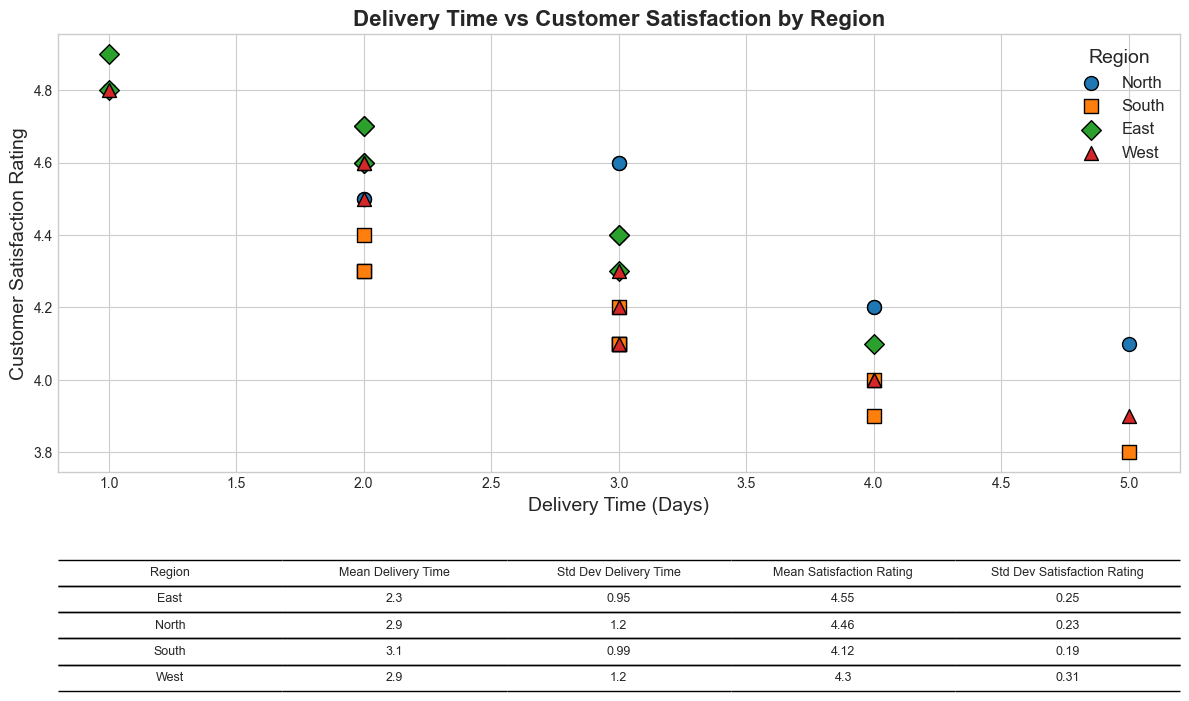What is the average delivery time for the North region? The table in the chart shows the mean delivery time for each region. For the North region, look for the value in the column labeled 'Mean Delivery Time' corresponding to 'North'.
Answer: 2.90 Which region has the highest average customer satisfaction rating? The table in the chart provides the mean satisfaction ratings for each region. Compare these values to determine the highest. The region with the highest value in the 'Mean Satisfaction Rating' column is East.
Answer: East What is the standard deviation of delivery time in the South region? From the table, find the row corresponding to the South region and look at the value under the 'Std Dev Delivery Time' column.
Answer: 1.14 Which region shows the lowest customer satisfaction rating on average? The table lists the mean satisfaction ratings for all regions. Identify the region with the lowest figure in the 'Mean Satisfaction Rating' column. The South region has the lowest average rating.
Answer: South How many points indicate a delivery time of 2 days in the East region? From the scatter plot, locate the East region points, identified by their specific color and marker, and count how many of these points are positioned at a delivery time of 2 days on the x-axis.
Answer: 4 Between which two regions is the difference in average delivery time the largest? Check the 'Mean Delivery Time' values for all regions in the table, then calculate the difference between each pair to identify the largest one. Compare the mean delivery times of the East (2.30 days) and South (3.10 days) regions. The difference is 0.80 days.
Answer: East and South Which region has the most variability in customer satisfaction ratings? The table shows the standard deviation for satisfaction ratings of each region. The region with the highest value in the 'Std Dev Satisfaction Rating' column represents the highest variability. North has the highest standard deviation.
Answer: North Does any region have both the highest mean delivery time and the highest standard deviation in delivery times? Compare the values in the table: the highest mean delivery time is 3.10 days (South) and the highest standard deviation in delivery times is 1.34 days (North). No single region has both the highest mean and highest variation.
Answer: No What is the correlation direction between delivery time and customer satisfaction in the West region? Examine the West region scatter plot points. Observe the trend: as delivery time decreases, customer satisfaction tends to increase. This represents a negative correlation.
Answer: Negative 